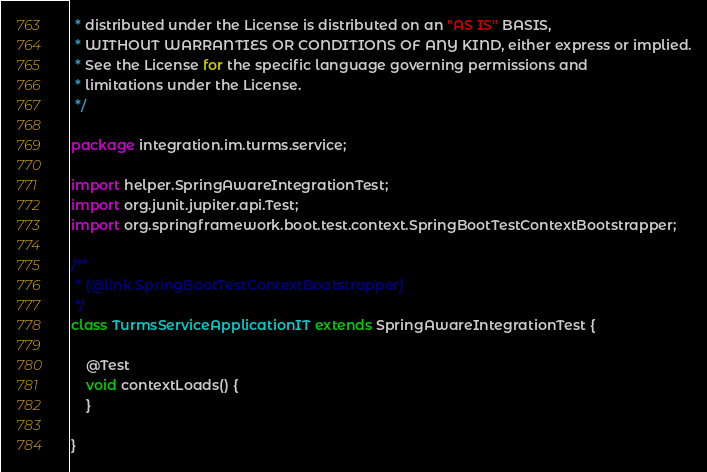Convert code to text. <code><loc_0><loc_0><loc_500><loc_500><_Java_> * distributed under the License is distributed on an "AS IS" BASIS,
 * WITHOUT WARRANTIES OR CONDITIONS OF ANY KIND, either express or implied.
 * See the License for the specific language governing permissions and
 * limitations under the License.
 */

package integration.im.turms.service;

import helper.SpringAwareIntegrationTest;
import org.junit.jupiter.api.Test;
import org.springframework.boot.test.context.SpringBootTestContextBootstrapper;

/**
 * {@link SpringBootTestContextBootstrapper}
 */
class TurmsServiceApplicationIT extends SpringAwareIntegrationTest {

    @Test
    void contextLoads() {
    }

}
</code> 